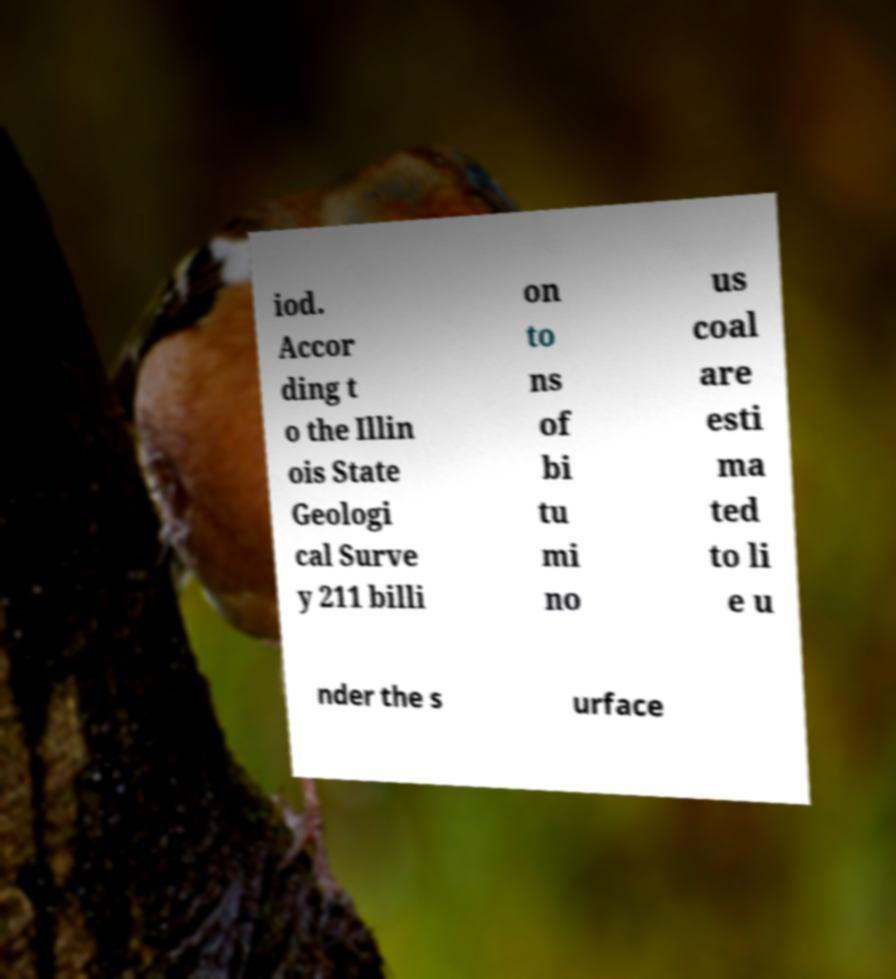Please identify and transcribe the text found in this image. iod. Accor ding t o the Illin ois State Geologi cal Surve y 211 billi on to ns of bi tu mi no us coal are esti ma ted to li e u nder the s urface 